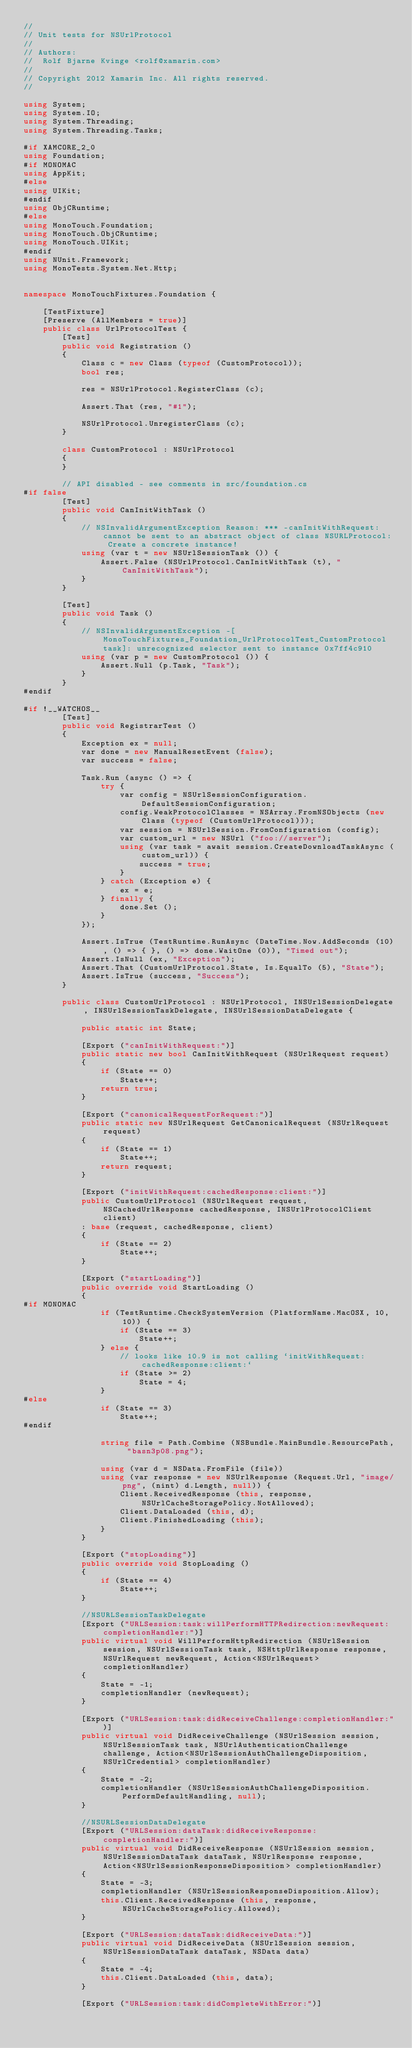<code> <loc_0><loc_0><loc_500><loc_500><_C#_>//
// Unit tests for NSUrlProtocol
//
// Authors:
//	Rolf Bjarne Kvinge <rolf@xamarin.com>
//
// Copyright 2012 Xamarin Inc. All rights reserved.
//

using System;
using System.IO;
using System.Threading;
using System.Threading.Tasks;

#if XAMCORE_2_0
using Foundation;
#if MONOMAC
using AppKit;
#else
using UIKit;
#endif
using ObjCRuntime;
#else
using MonoTouch.Foundation;
using MonoTouch.ObjCRuntime;
using MonoTouch.UIKit;
#endif
using NUnit.Framework;
using MonoTests.System.Net.Http;


namespace MonoTouchFixtures.Foundation {
	
	[TestFixture]
	[Preserve (AllMembers = true)]
	public class UrlProtocolTest {
		[Test]
		public void Registration ()
		{
			Class c = new Class (typeof (CustomProtocol));
			bool res;
			
			res = NSUrlProtocol.RegisterClass (c);
			
			Assert.That (res, "#1");
			
			NSUrlProtocol.UnregisterClass (c);
		}

		class CustomProtocol : NSUrlProtocol
		{
		}

		// API disabled - see comments in src/foundation.cs
#if false
		[Test]
		public void CanInitWithTask ()
		{
			// NSInvalidArgumentException Reason: *** -canInitWithRequest: cannot be sent to an abstract object of class NSURLProtocol: Create a concrete instance!
			using (var t = new NSUrlSessionTask ()) {
				Assert.False (NSUrlProtocol.CanInitWithTask (t), "CanInitWithTask");
			}
		}

		[Test]
		public void Task ()
		{
			// NSInvalidArgumentException -[MonoTouchFixtures_Foundation_UrlProtocolTest_CustomProtocol task]: unrecognized selector sent to instance 0x7ff4c910
			using (var p = new CustomProtocol ()) {
				Assert.Null (p.Task, "Task");
			}
		}
#endif

#if !__WATCHOS__
		[Test]
		public void RegistrarTest ()
		{
			Exception ex = null;
			var done = new ManualResetEvent (false);
			var success = false;

			Task.Run (async () => {
				try {
					var config = NSUrlSessionConfiguration.DefaultSessionConfiguration;
					config.WeakProtocolClasses = NSArray.FromNSObjects (new Class (typeof (CustomUrlProtocol)));
					var session = NSUrlSession.FromConfiguration (config);
					var custom_url = new NSUrl ("foo://server");
					using (var task = await session.CreateDownloadTaskAsync (custom_url)) {
						success = true;
					}
				} catch (Exception e) {
					ex = e;
				} finally {
					done.Set ();
				}
			});

			Assert.IsTrue (TestRuntime.RunAsync (DateTime.Now.AddSeconds (10), () => { }, () => done.WaitOne (0)), "Timed out");
			Assert.IsNull (ex, "Exception");
			Assert.That (CustomUrlProtocol.State, Is.EqualTo (5), "State");
			Assert.IsTrue (success, "Success");
		}

		public class CustomUrlProtocol : NSUrlProtocol, INSUrlSessionDelegate, INSUrlSessionTaskDelegate, INSUrlSessionDataDelegate {

			public static int State;

			[Export ("canInitWithRequest:")]
			public static new bool CanInitWithRequest (NSUrlRequest request)
			{
				if (State == 0)
					State++;
				return true;
			}

			[Export ("canonicalRequestForRequest:")]
			public static new NSUrlRequest GetCanonicalRequest (NSUrlRequest request)
			{
				if (State == 1)
					State++;
				return request;
			}

			[Export ("initWithRequest:cachedResponse:client:")]
			public CustomUrlProtocol (NSUrlRequest request, NSCachedUrlResponse cachedResponse, INSUrlProtocolClient client)
			: base (request, cachedResponse, client)
			{
				if (State == 2)
					State++;
			}

			[Export ("startLoading")]
			public override void StartLoading ()
			{
#if MONOMAC
				if (TestRuntime.CheckSystemVersion (PlatformName.MacOSX, 10, 10)) {
					if (State == 3)
						State++;
				} else {
					// looks like 10.9 is not calling `initWithRequest:cachedResponse:client:`
					if (State >= 2)
						State = 4;
				}
#else
				if (State == 3)
					State++;
#endif

				string file = Path.Combine (NSBundle.MainBundle.ResourcePath, "basn3p08.png");

				using (var d = NSData.FromFile (file))
				using (var response = new NSUrlResponse (Request.Url, "image/png", (nint) d.Length, null)) {
					Client.ReceivedResponse (this, response, NSUrlCacheStoragePolicy.NotAllowed);
					Client.DataLoaded (this, d);
					Client.FinishedLoading (this);
				}
			}

			[Export ("stopLoading")]
			public override void StopLoading ()
			{
				if (State == 4)
					State++;
			}

			//NSURLSessionTaskDelegate
			[Export ("URLSession:task:willPerformHTTPRedirection:newRequest:completionHandler:")]
			public virtual void WillPerformHttpRedirection (NSUrlSession session, NSUrlSessionTask task, NSHttpUrlResponse response, NSUrlRequest newRequest, Action<NSUrlRequest> completionHandler)
			{
				State = -1;
				completionHandler (newRequest);
			}

			[Export ("URLSession:task:didReceiveChallenge:completionHandler:")]
			public virtual void DidReceiveChallenge (NSUrlSession session, NSUrlSessionTask task, NSUrlAuthenticationChallenge challenge, Action<NSUrlSessionAuthChallengeDisposition, NSUrlCredential> completionHandler)
			{
				State = -2;
				completionHandler (NSUrlSessionAuthChallengeDisposition.PerformDefaultHandling, null);
			}

			//NSURLSessionDataDelegate
			[Export ("URLSession:dataTask:didReceiveResponse:completionHandler:")]
			public virtual void DidReceiveResponse (NSUrlSession session, NSUrlSessionDataTask dataTask, NSUrlResponse response, Action<NSUrlSessionResponseDisposition> completionHandler)
			{
				State = -3;
				completionHandler (NSUrlSessionResponseDisposition.Allow);
				this.Client.ReceivedResponse (this, response, NSUrlCacheStoragePolicy.Allowed);
			}

			[Export ("URLSession:dataTask:didReceiveData:")]
			public virtual void DidReceiveData (NSUrlSession session, NSUrlSessionDataTask dataTask, NSData data)
			{
				State = -4;
				this.Client.DataLoaded (this, data);
			}

			[Export ("URLSession:task:didCompleteWithError:")]</code> 